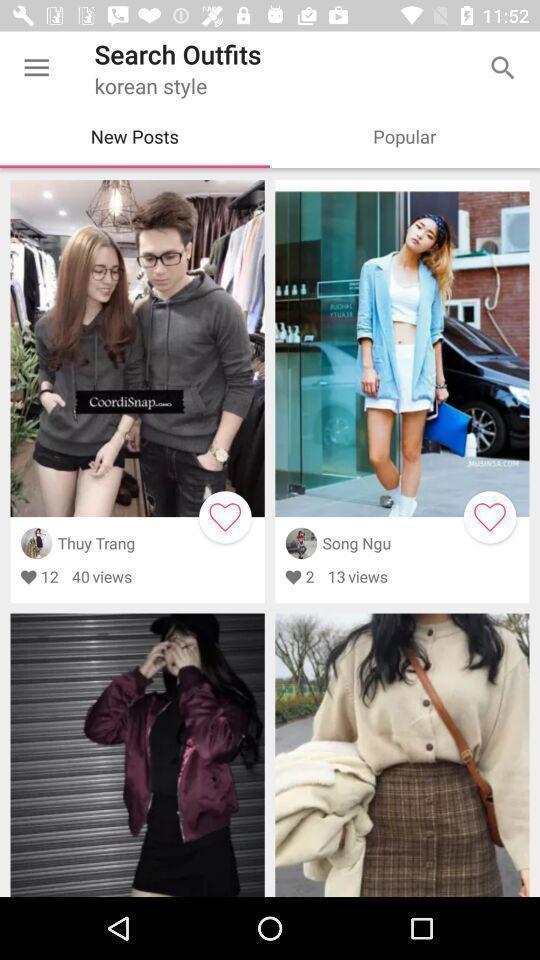Describe the visual elements of this screenshot. Window displaying the uploaded photos. 